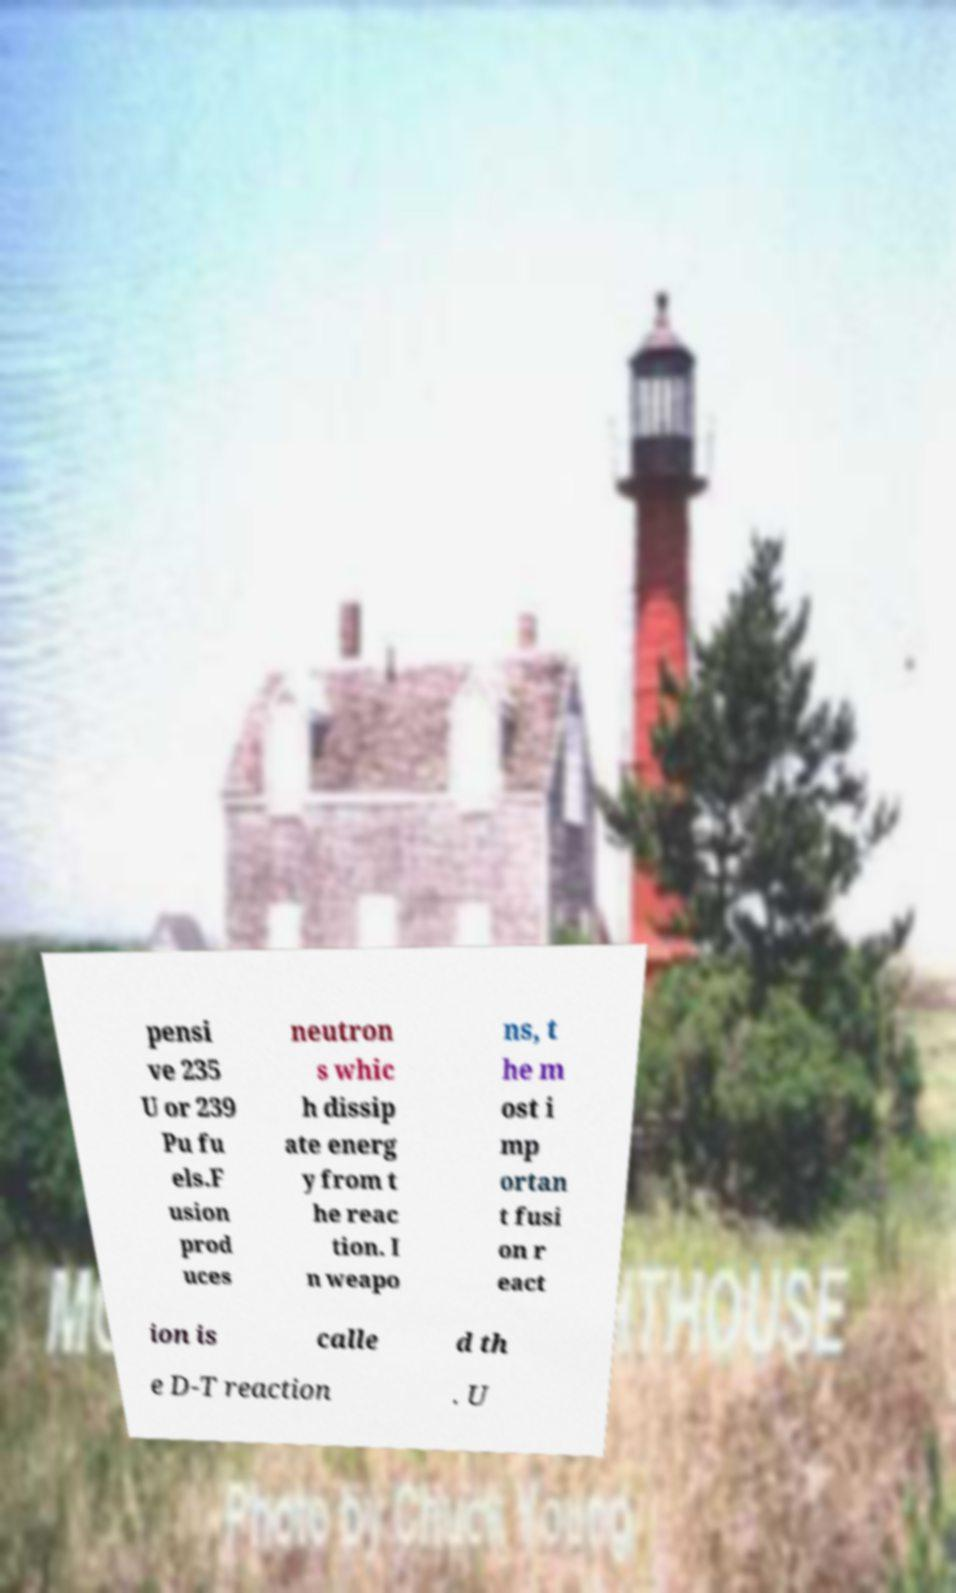Please read and relay the text visible in this image. What does it say? pensi ve 235 U or 239 Pu fu els.F usion prod uces neutron s whic h dissip ate energ y from t he reac tion. I n weapo ns, t he m ost i mp ortan t fusi on r eact ion is calle d th e D-T reaction . U 